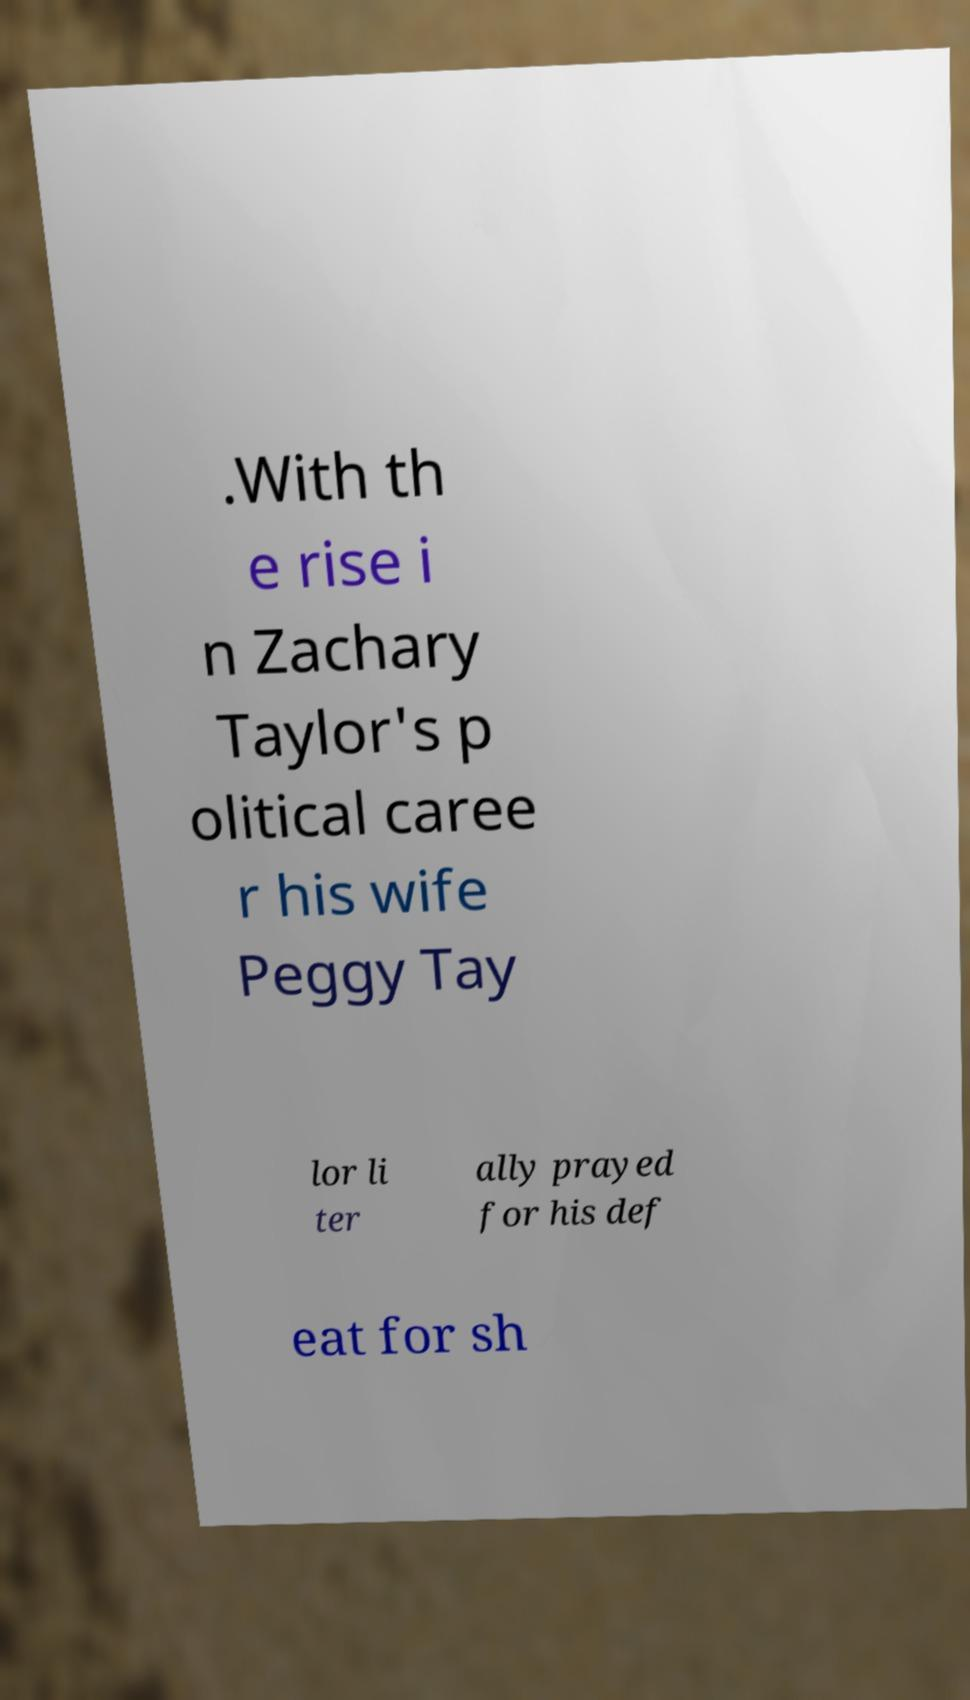There's text embedded in this image that I need extracted. Can you transcribe it verbatim? .With th e rise i n Zachary Taylor's p olitical caree r his wife Peggy Tay lor li ter ally prayed for his def eat for sh 